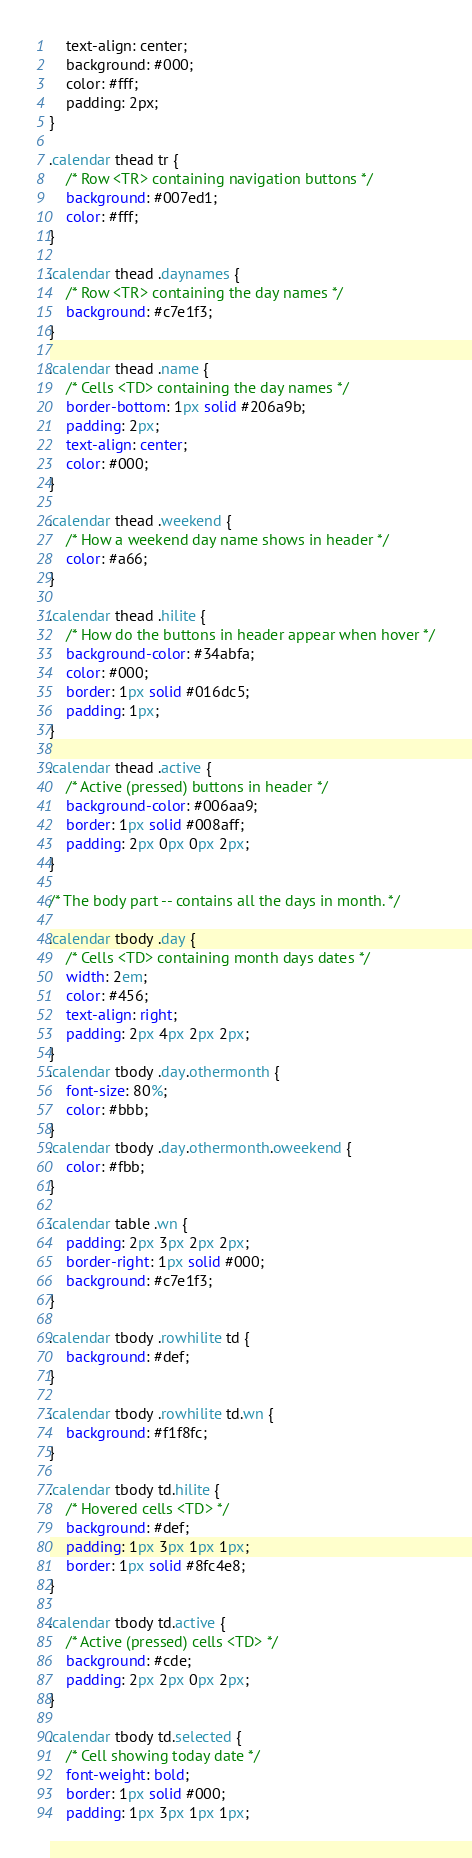Convert code to text. <code><loc_0><loc_0><loc_500><loc_500><_CSS_>	text-align: center;
	background: #000;
	color: #fff;
	padding: 2px;
}

.calendar thead tr {
	/* Row <TR> containing navigation buttons */
	background: #007ed1;
	color: #fff;
}

.calendar thead .daynames {
	/* Row <TR> containing the day names */
	background: #c7e1f3;
}

.calendar thead .name {
	/* Cells <TD> containing the day names */
	border-bottom: 1px solid #206a9b;
	padding: 2px;
	text-align: center;
	color: #000;
}

.calendar thead .weekend {
	/* How a weekend day name shows in header */
	color: #a66;
}

.calendar thead .hilite {
	/* How do the buttons in header appear when hover */
	background-color: #34abfa;
	color: #000;
	border: 1px solid #016dc5;
	padding: 1px;
}

.calendar thead .active {
	/* Active (pressed) buttons in header */
	background-color: #006aa9;
	border: 1px solid #008aff;
	padding: 2px 0px 0px 2px;
}

/* The body part -- contains all the days in month. */

.calendar tbody .day {
	/* Cells <TD> containing month days dates */
	width: 2em;
	color: #456;
	text-align: right;
	padding: 2px 4px 2px 2px;
}
.calendar tbody .day.othermonth {
	font-size: 80%;
	color: #bbb;
}
.calendar tbody .day.othermonth.oweekend {
	color: #fbb;
}

.calendar table .wn {
	padding: 2px 3px 2px 2px;
	border-right: 1px solid #000;
	background: #c7e1f3;
}

.calendar tbody .rowhilite td {
	background: #def;
}

.calendar tbody .rowhilite td.wn {
	background: #f1f8fc;
}

.calendar tbody td.hilite {
	/* Hovered cells <TD> */
	background: #def;
	padding: 1px 3px 1px 1px;
	border: 1px solid #8fc4e8;
}

.calendar tbody td.active {
	/* Active (pressed) cells <TD> */
	background: #cde;
	padding: 2px 2px 0px 2px;
}

.calendar tbody td.selected {
	/* Cell showing today date */
	font-weight: bold;
	border: 1px solid #000;
	padding: 1px 3px 1px 1px;</code> 